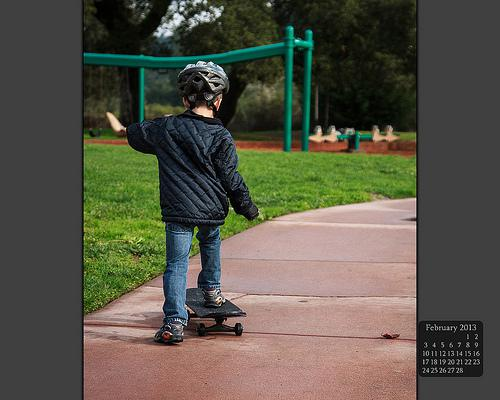Question: what surface is the skateboard on?
Choices:
A. Gravel. Yikes.
B. Sidewalk.
C. A hardwood floor.
D. A tennis court.
Answer with the letter. Answer: B Question: why is his arm out?
Choices:
A. For Balance.
B. He is turning left.
C. He is catching a ball.
D. He is hitchhiking.
Answer with the letter. Answer: A Question: what type of Shoes does he have on?
Choices:
A. Bowling shoes.
B. Tennis Shoes.
C. Sneakers for basketball.
D. Running shoes.
Answer with the letter. Answer: B 